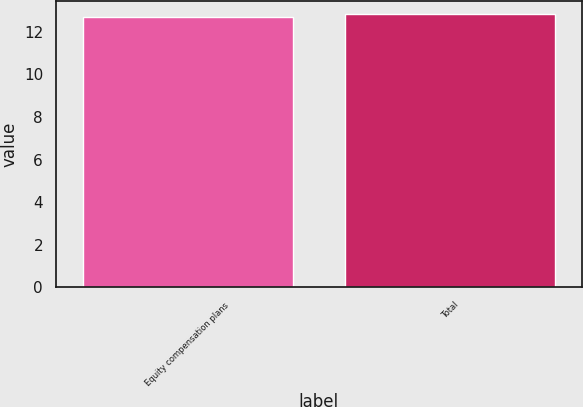Convert chart. <chart><loc_0><loc_0><loc_500><loc_500><bar_chart><fcel>Equity compensation plans<fcel>Total<nl><fcel>12.71<fcel>12.81<nl></chart> 